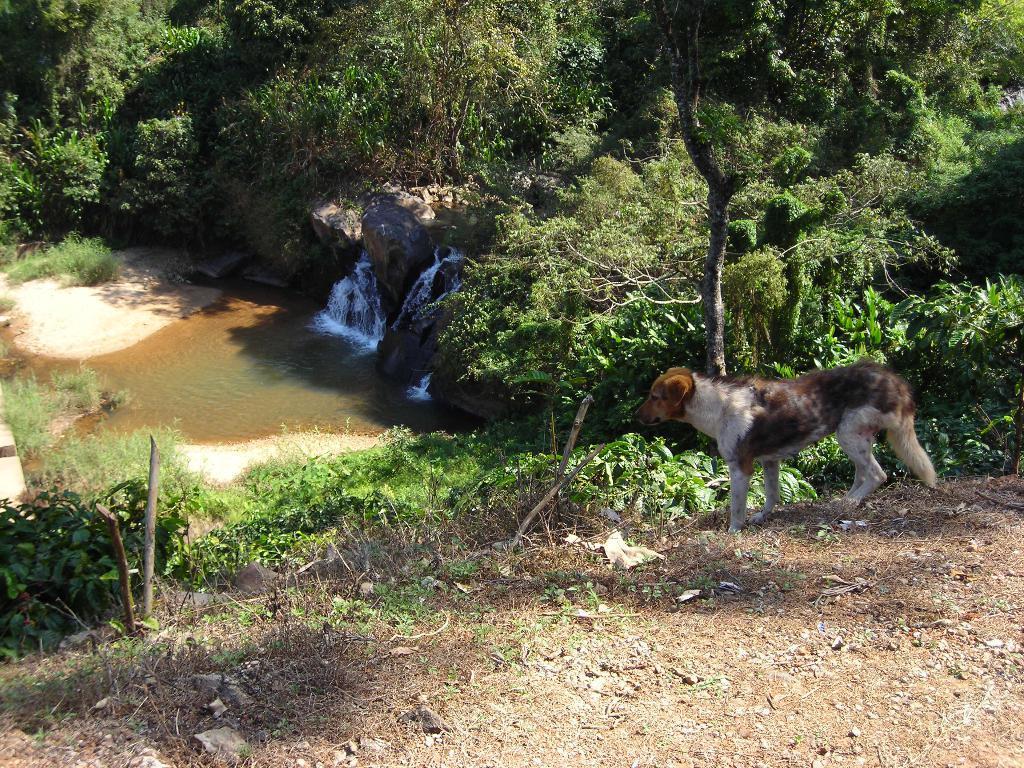How would you summarize this image in a sentence or two? In this image, we can see a dog and in the background, there are trees, rocks and there is water. At the bottom, there is ground. 